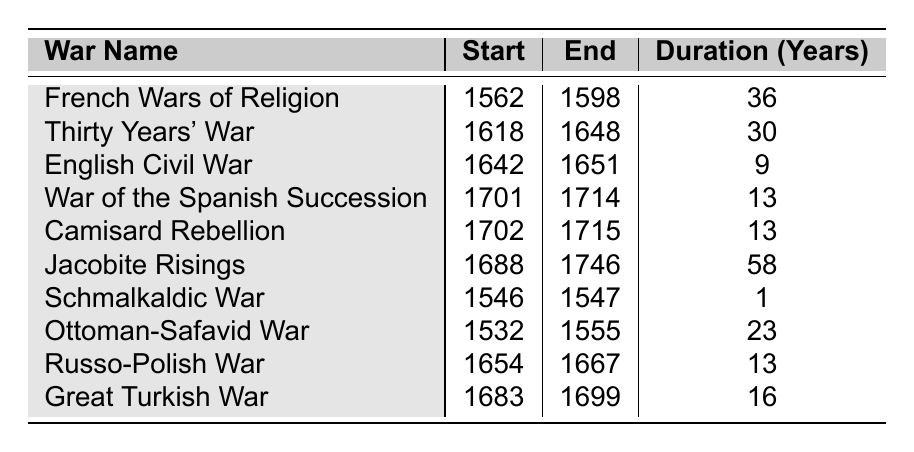What is the duration of the French Wars of Religion? The table lists the French Wars of Religion with its duration explicitly given as 36 years.
Answer: 36 years Which war has the longest duration? The table shows that the Jacobite Risings have a duration of 58 years, which is greater than any other listed war.
Answer: Jacobite Risings What is the total duration of the English Civil War and the War of the Spanish Succession combined? The English Civil War lasts 9 years, and the War of the Spanish Succession lasts 13 years. Adding these gives 9 + 13 = 22 years.
Answer: 22 years Did the Ottoman-Safavid War occur before the French Wars of Religion? The Ottoman-Safavid War started in 1532 and ended in 1555, whereas the French Wars of Religion began in 1562, so it happened earlier.
Answer: Yes What is the difference in duration between the Thirty Years' War and the Great Turkish War? The Thirty Years' War lasted 30 years, while the Great Turkish War lasted 16 years. The difference is 30 - 16 = 14 years.
Answer: 14 years How many wars lasted longer than 15 years? By examining the table, we see that the wars with durations above 15 years are the French Wars of Religion (36), Thirty Years' War (30), Jacobite Risings (58), and Great Turkish War (16). That makes a total of 4 wars.
Answer: 4 wars Which war started in the same year as the War of the Spanish Succession? The Camisard Rebellion also started in 1702, which is the same year as the War of the Spanish Succession, which started in 1701.
Answer: None; Camisard Rebellion started in 1702 What is the average duration of all the wars listed? To calculate the average, add all durations: 36 + 30 + 9 + 13 + 13 + 58 + 1 + 23 + 13 + 16 =  222. There are 10 wars, thus average = 222 / 10 = 22.2 years.
Answer: 22.2 years Which war had the shortest duration, and how long did it last? The Schmalkaldic War lasted only 1 year, as shown in the table.
Answer: Schmalkaldic War; 1 year How many wars occurred in the 17th century? Looking at the table, the wars that occurred in the 17th century are the Thirty Years' War, English Civil War, Russo-Polish War, Great Turkish War, and Jacobite Risings. That adds up to 5 wars.
Answer: 5 wars 